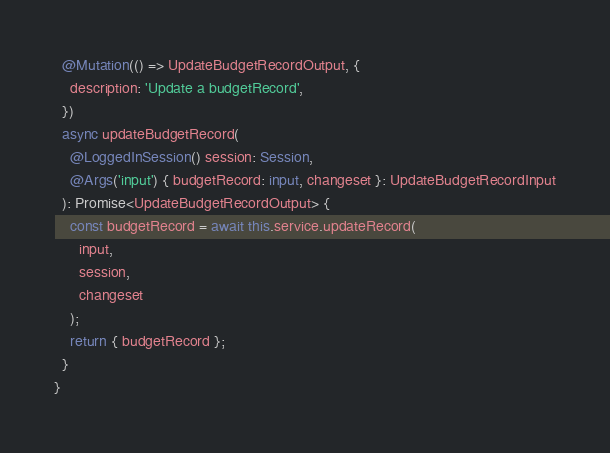<code> <loc_0><loc_0><loc_500><loc_500><_TypeScript_>
  @Mutation(() => UpdateBudgetRecordOutput, {
    description: 'Update a budgetRecord',
  })
  async updateBudgetRecord(
    @LoggedInSession() session: Session,
    @Args('input') { budgetRecord: input, changeset }: UpdateBudgetRecordInput
  ): Promise<UpdateBudgetRecordOutput> {
    const budgetRecord = await this.service.updateRecord(
      input,
      session,
      changeset
    );
    return { budgetRecord };
  }
}
</code> 